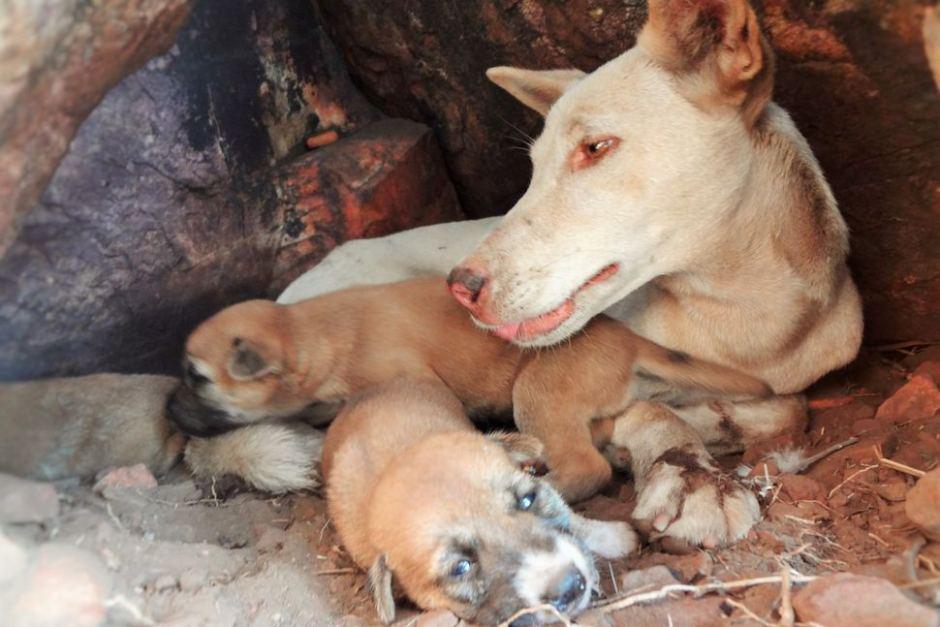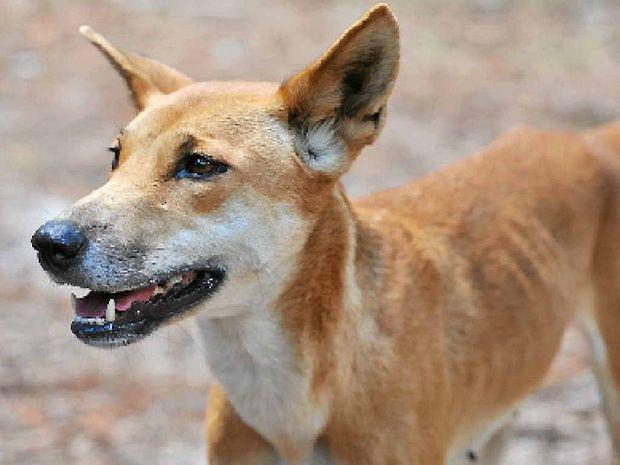The first image is the image on the left, the second image is the image on the right. Considering the images on both sides, is "At least one person is behind exactly two young dogs in the right image." valid? Answer yes or no. No. The first image is the image on the left, the second image is the image on the right. For the images shown, is this caption "In the image on the right there are 2 puppies." true? Answer yes or no. No. 